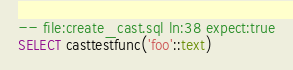<code> <loc_0><loc_0><loc_500><loc_500><_SQL_>-- file:create_cast.sql ln:38 expect:true
SELECT casttestfunc('foo'::text)
</code> 